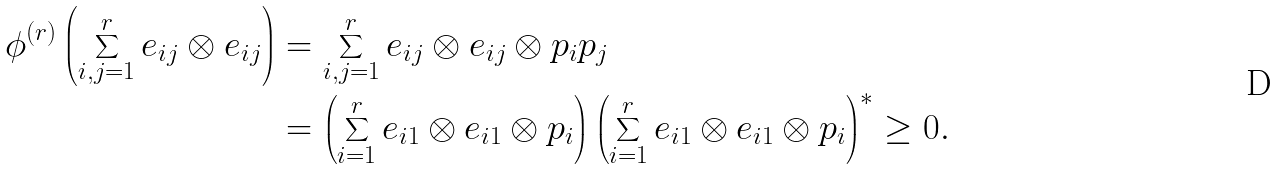<formula> <loc_0><loc_0><loc_500><loc_500>\phi ^ { ( r ) } \left ( \sum _ { i , j = 1 } ^ { r } e _ { i j } \otimes e _ { i j } \right ) & = \sum _ { i , j = 1 } ^ { r } e _ { i j } \otimes e _ { i j } \otimes p _ { i } p _ { j } \\ & = \left ( \sum _ { i = 1 } ^ { r } e _ { i 1 } \otimes e _ { i 1 } \otimes p _ { i } \right ) \left ( \sum _ { i = 1 } ^ { r } e _ { i 1 } \otimes e _ { i 1 } \otimes p _ { i } \right ) ^ { * } \geq 0 .</formula> 